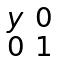<formula> <loc_0><loc_0><loc_500><loc_500>\begin{smallmatrix} y & 0 \\ 0 & 1 \\ \end{smallmatrix}</formula> 